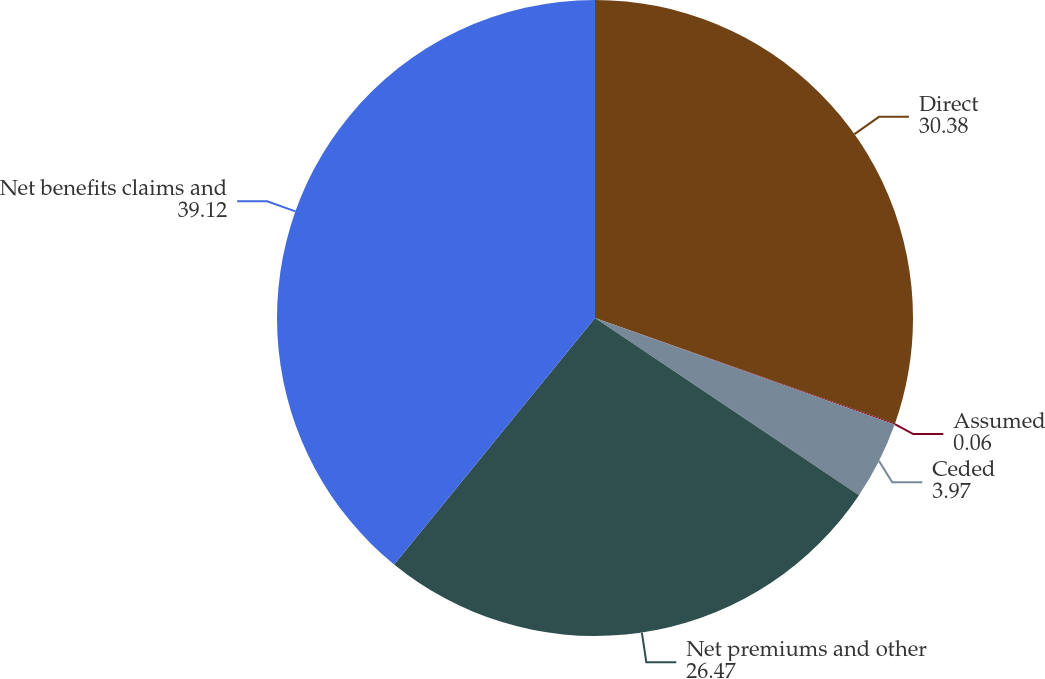<chart> <loc_0><loc_0><loc_500><loc_500><pie_chart><fcel>Direct<fcel>Assumed<fcel>Ceded<fcel>Net premiums and other<fcel>Net benefits claims and<nl><fcel>30.38%<fcel>0.06%<fcel>3.97%<fcel>26.47%<fcel>39.12%<nl></chart> 